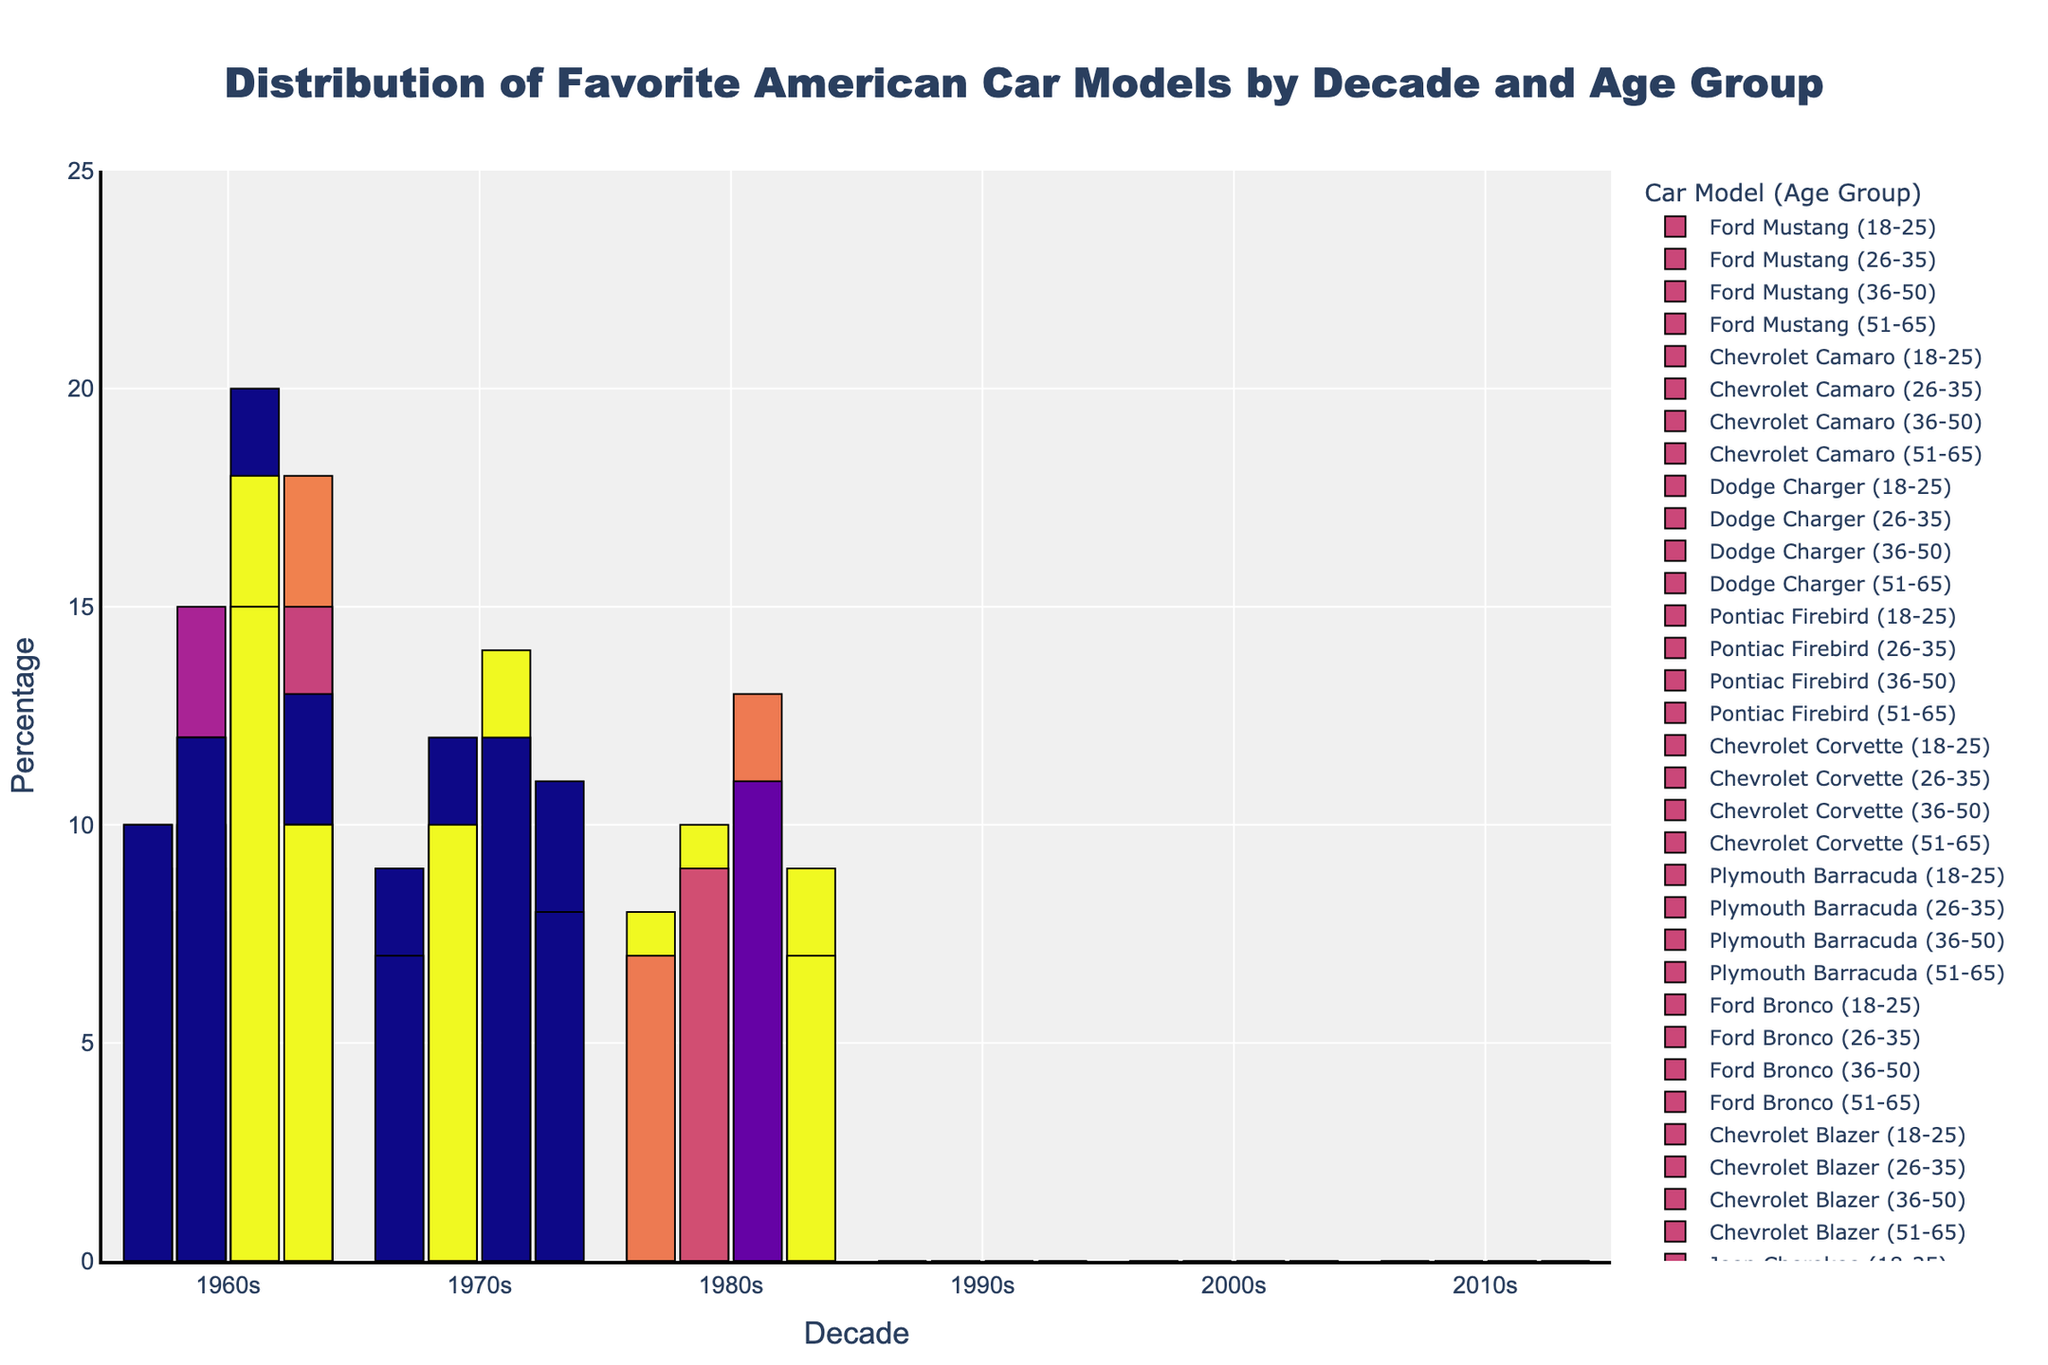Which age group had the highest percentage of favorite cars from the 1960s? Look at the bars for each age group in the 1960s section and identify the tallest bar. The 36-50 age group shows the highest percentage for any car model, specifically the Ford Mustang with 20%.
Answer: 36-50 Which decade shows the lowest popularity (by percentage) for the Dodge Charger across all age groups? Check the height of the bars representing the Dodge Charger in every decade. The 2000s have no representation of the Dodge Charger, indicating 0% popularity.
Answer: 2000s How does the popularity of the Chevrolet Camaro in the 2010s among the 18-25 age group compare to the 18-25 age group in the 2000s? Compare the height of the bars for the Chevrolet Camaro in the 2010s and 2000s for the 18-25 age group. The height signifies the percentage, with 7% in the 2010s and 7% in the 2000s, indicating they are equal.
Answer: Equal Which model saw an increase in popularity across all age groups from the 2000s to the 2010s? By comparing the bars for each model in the 2000s and 2010s segments, observe any model that consistently has taller bars in the 2010s. Tesla Model S shows an increase across all age groups from the 2000s to the 2010s.
Answer: Tesla Model S Did the interest in the Ford Mustang among the 36-50 age group increase or decrease from the 1960s to the 2000s? Compare the heights of the Ford Mustang bars for the 36-50 age group in the 1960s and the 2000s. The percentage is 20% in the 1960s and 14% in the 2000s, indicating a decrease.
Answer: Decrease Among the 26-35 age group in the 1970s, which model had the lowest percentage of favorites? Look at the bar heights for each model in the 26-35 age group for the 1970s and identify the shortest bar. Plymouth Barracuda had the lowest percentage at 8%.
Answer: Plymouth Barracuda Which decade features the widest variety of car models in terms of the number of different models favored across all age groups? Count the distinct models in each decade segment. The 2010s include the Tesla Model S, Ford Mustang, and Chevrolet Camaro, whereas other decades feature fewer models.
Answer: 2010s Which age group showed the highest preference for the Ford Bronco in the 1980s? Check the heights of the Ford Bronco bars in the 1980s for each age group. The 36-50 age group has the highest bar at 12%.
Answer: 36-50 Has the percentage of favorites for the Chevrolet Blazer among the 51-65 age group increased or decreased from the 1980s to the 1990s? Compare the heights of the Chevrolet Blazer bars for the 51-65 age group in the 1980s and 1990s. The 1980s have 8% and the 1990s have 8%, thus the percentage has remained the same.
Answer: Same 